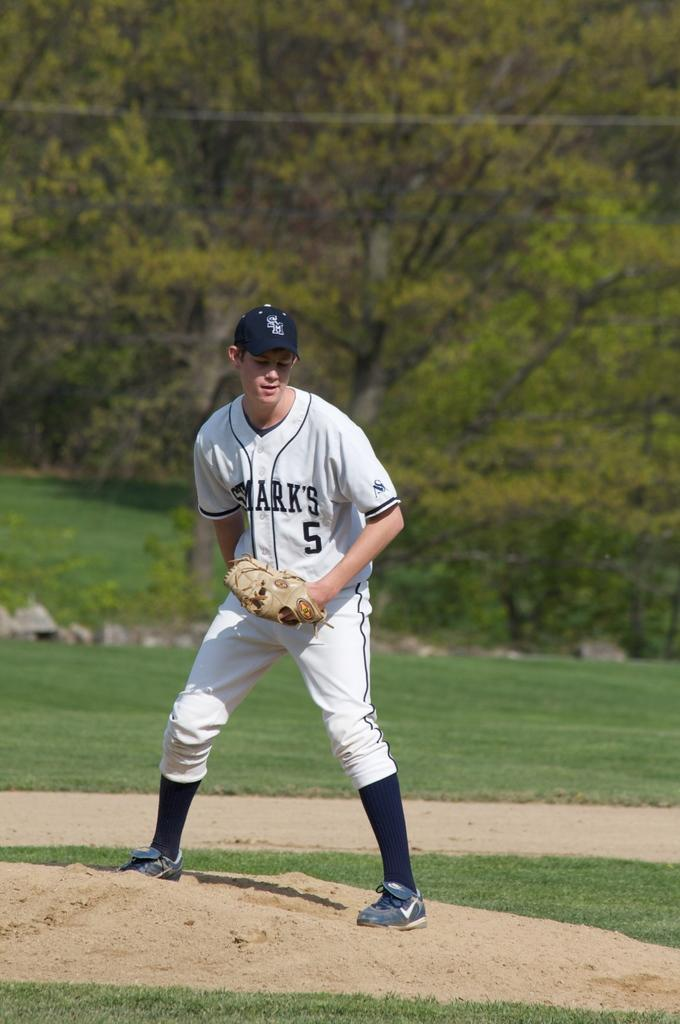<image>
Present a compact description of the photo's key features. Player number 5 for the Sharks prepares to face a batter in a baseball game. 